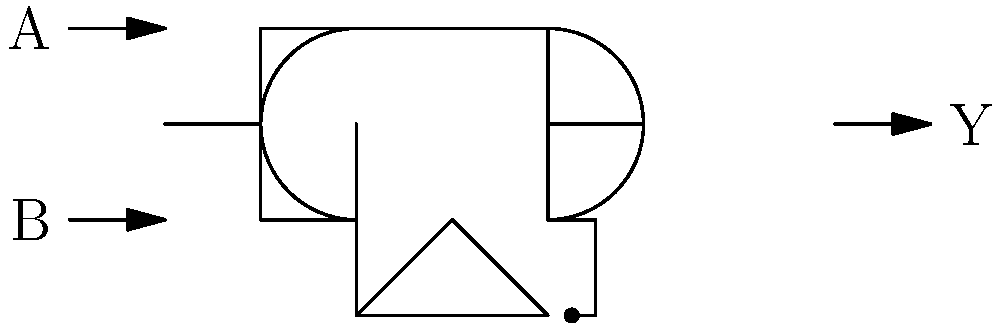For the given digital circuit, determine the boolean expression for output Y in terms of inputs A and B, and construct its truth table. To solve this problem, let's follow these steps:

1. Analyze the circuit:
   - The circuit consists of an AND gate, an OR gate, and a NOT gate.
   - Input A goes directly to the AND gate.
   - Input B goes to both the AND gate and the NOT gate.

2. Determine the boolean expression:
   - The output of the AND gate is $A \cdot B$
   - The output of the NOT gate is $\overline{B}$
   - The OR gate combines these outputs: $Y = (A \cdot B) + \overline{B}$

3. Simplify the expression:
   - $Y = (A \cdot B) + \overline{B}$
   - This expression can't be simplified further using boolean algebra.

4. Construct the truth table:
   - We need to evaluate Y for all possible combinations of A and B.

   | A | B | $A \cdot B$ | $\overline{B}$ | $Y = (A \cdot B) + \overline{B}$ |
   |---|---|-------------|----------------|----------------------------------|
   | 0 | 0 |     0       |       1        |               1                  |
   | 0 | 1 |     0       |       0        |               0                  |
   | 1 | 0 |     0       |       1        |               1                  |
   | 1 | 1 |     1       |       0        |               1                  |

5. Verify the truth table:
   - When B is 0, $\overline{B}$ is 1, so Y is always 1 regardless of A.
   - When B is 1, $\overline{B}$ is 0, so Y depends on the AND operation between A and B.

The boolean expression and truth table accurately represent the behavior of the given circuit.
Answer: $Y = (A \cdot B) + \overline{B}$; Truth table: Y = 1 when B = 0 or A = B = 1, otherwise Y = 0. 